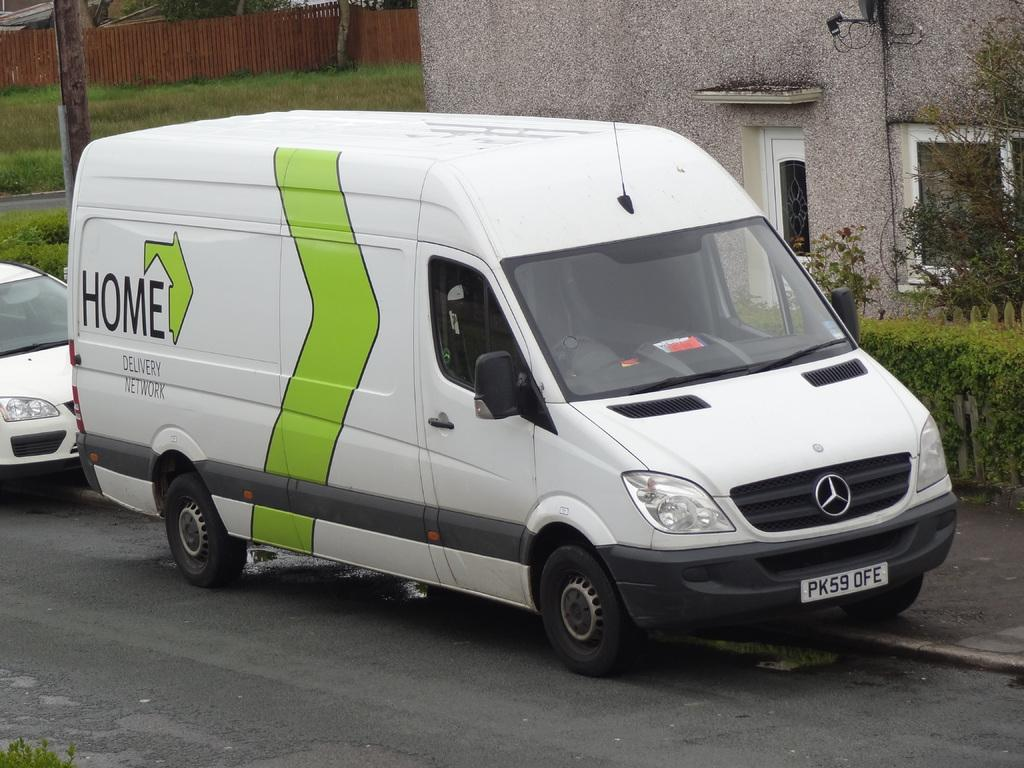<image>
Present a compact description of the photo's key features. A white Mercedes van says Home on the side and is parked by a building. 